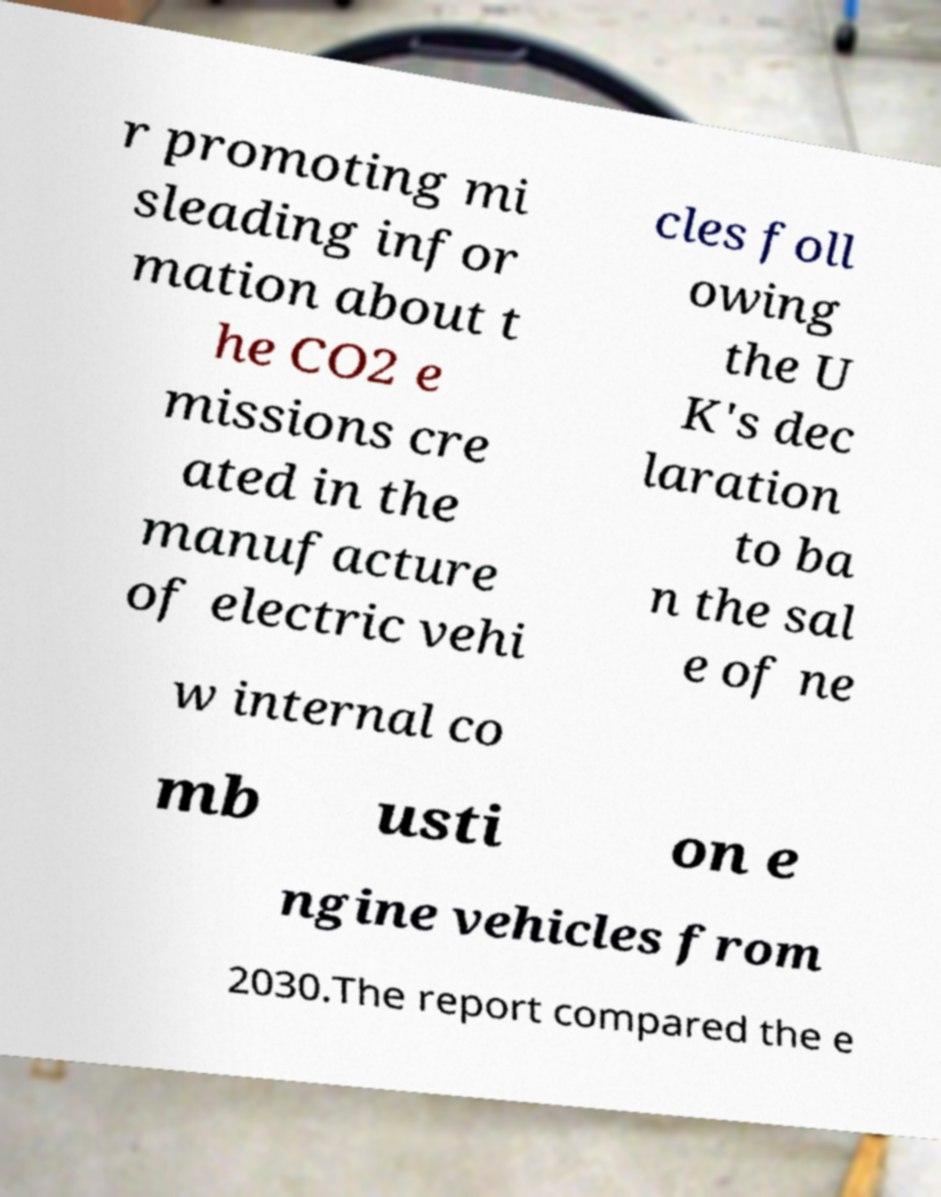What messages or text are displayed in this image? I need them in a readable, typed format. r promoting mi sleading infor mation about t he CO2 e missions cre ated in the manufacture of electric vehi cles foll owing the U K's dec laration to ba n the sal e of ne w internal co mb usti on e ngine vehicles from 2030.The report compared the e 